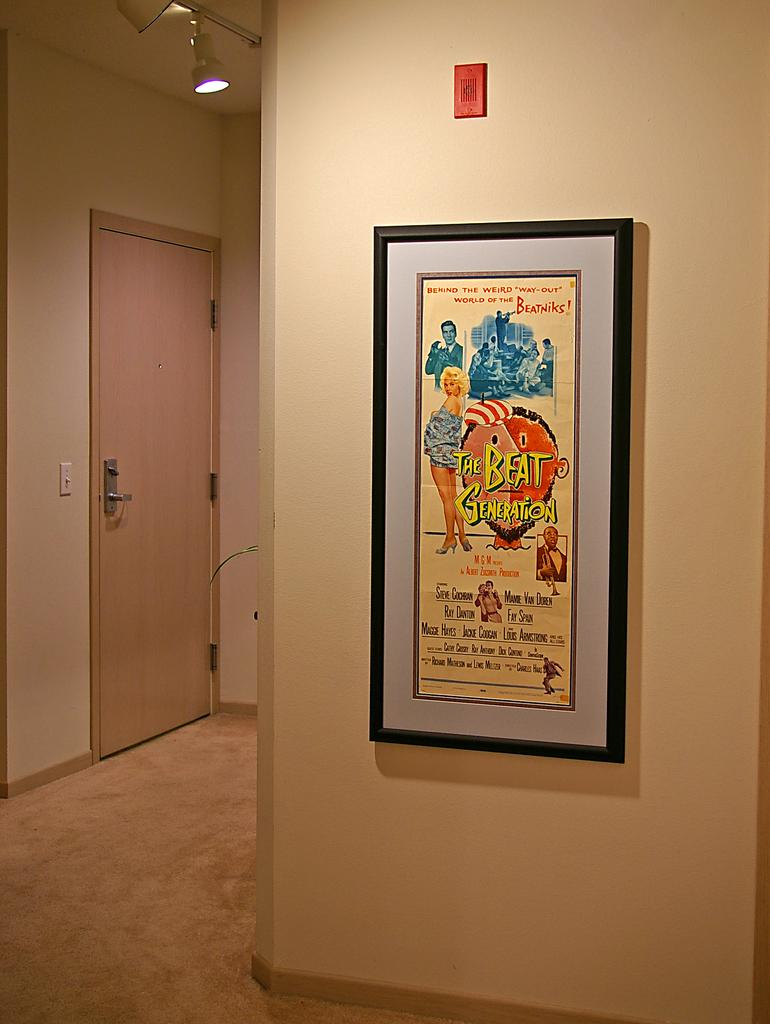<image>
Give a short and clear explanation of the subsequent image. A poster hung on the wall displays The Beat Generation, Behind the Weird Way-Out of the Beatniks! 